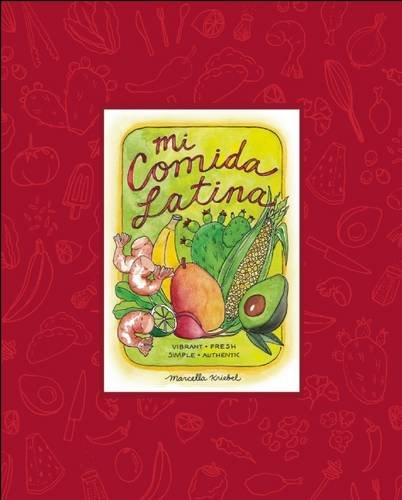What type of book is this? This is a cookbook under the 'Food & Wine' category, beautifully illustrating recipes that emphasize fresh, vibrant, and authentic Latin American flavors. 